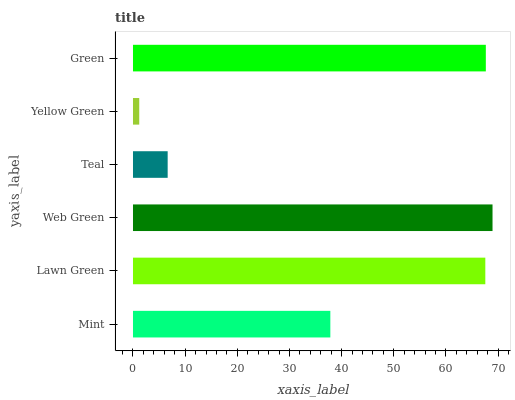Is Yellow Green the minimum?
Answer yes or no. Yes. Is Web Green the maximum?
Answer yes or no. Yes. Is Lawn Green the minimum?
Answer yes or no. No. Is Lawn Green the maximum?
Answer yes or no. No. Is Lawn Green greater than Mint?
Answer yes or no. Yes. Is Mint less than Lawn Green?
Answer yes or no. Yes. Is Mint greater than Lawn Green?
Answer yes or no. No. Is Lawn Green less than Mint?
Answer yes or no. No. Is Lawn Green the high median?
Answer yes or no. Yes. Is Mint the low median?
Answer yes or no. Yes. Is Teal the high median?
Answer yes or no. No. Is Teal the low median?
Answer yes or no. No. 